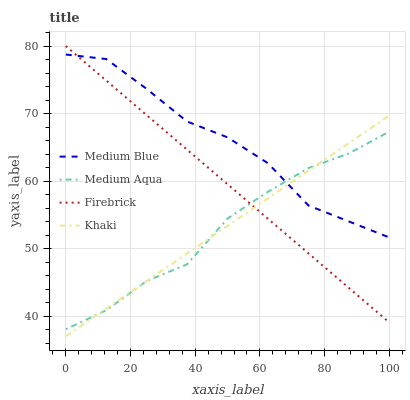Does Medium Aqua have the minimum area under the curve?
Answer yes or no. Yes. Does Medium Blue have the maximum area under the curve?
Answer yes or no. Yes. Does Firebrick have the minimum area under the curve?
Answer yes or no. No. Does Firebrick have the maximum area under the curve?
Answer yes or no. No. Is Firebrick the smoothest?
Answer yes or no. Yes. Is Medium Blue the roughest?
Answer yes or no. Yes. Is Khaki the smoothest?
Answer yes or no. No. Is Khaki the roughest?
Answer yes or no. No. Does Khaki have the lowest value?
Answer yes or no. Yes. Does Firebrick have the lowest value?
Answer yes or no. No. Does Firebrick have the highest value?
Answer yes or no. Yes. Does Khaki have the highest value?
Answer yes or no. No. Does Medium Blue intersect Firebrick?
Answer yes or no. Yes. Is Medium Blue less than Firebrick?
Answer yes or no. No. Is Medium Blue greater than Firebrick?
Answer yes or no. No. 